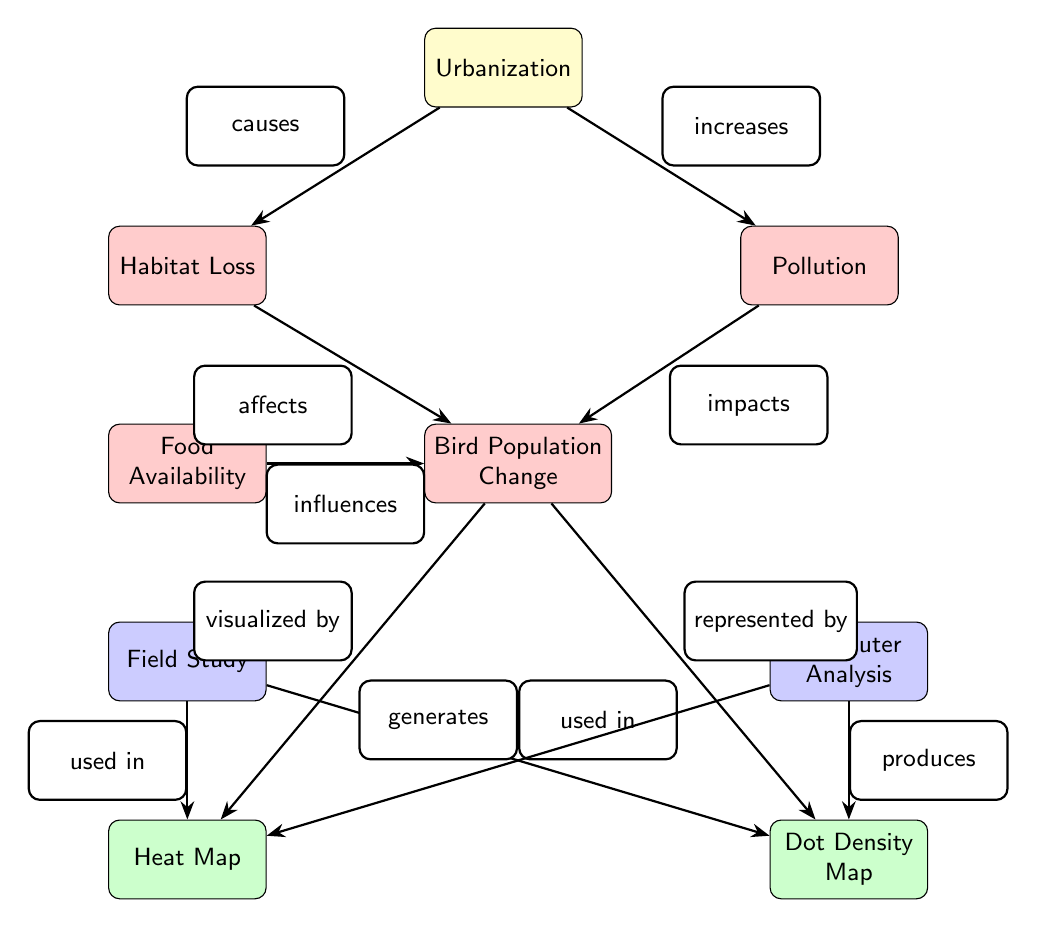What is the main cause of habitat loss? The diagram shows that habitat loss is caused by urbanization, as indicated by the arrow labeled "causes" connecting "Urbanization" to "Habitat Loss."
Answer: Urbanization How many impacts are directly related to urbanization? The diagram illustrates two impacts directly related to urbanization: habitat loss and pollution. Each impact is connected to the "Urbanization" node. Therefore, the answer is two.
Answer: 2 What does food availability influence? According to the diagram, food availability influences bird population change, as indicated by the arrow labeled "influences" connecting "Food Availability" to "Bird Population Change."
Answer: Bird Population Change Which analysis method is used to create the heat map? The edge labeled "used in" from the "Field Study" node to the "Heat Map" node indicates that the field study is an analysis method used to create the heat map.
Answer: Field Study What two visualization methods represent bird population change? The diagram shows that the bird population change is visualized by both a heat map and represented by a dot density map, as indicated by the labels connecting these visualization nodes to "Bird Population Change."
Answer: Heat Map and Dot Density Map How does pollution impact bird population change? The diagram highlights that pollution impacts bird population change through the labeled edge "impacts" connecting the "Pollution" node to the "Bird Population Change" node.
Answer: Impacts Which study uses both heat maps and dot density maps? The diagram indicates that the field study uses both visualization methods, as represented by the edges connecting the "Field Study" node to both the "Heat Map" and "Dot Density Map" nodes.
Answer: Field Study What is directly affected by habitat loss? The diagram illustrates that habitat loss affects bird population change, as shown by the arrow labeled "affects" connecting "Habitat Loss" to "Bird Population Change."
Answer: Bird Population Change In how many ways can bird population change be analyzed? The diagram outlines two distinct methods of analysis for bird population change: field study and computer analysis, as indicated by the two edges connecting to the "Bird Population Change" node.
Answer: 2 